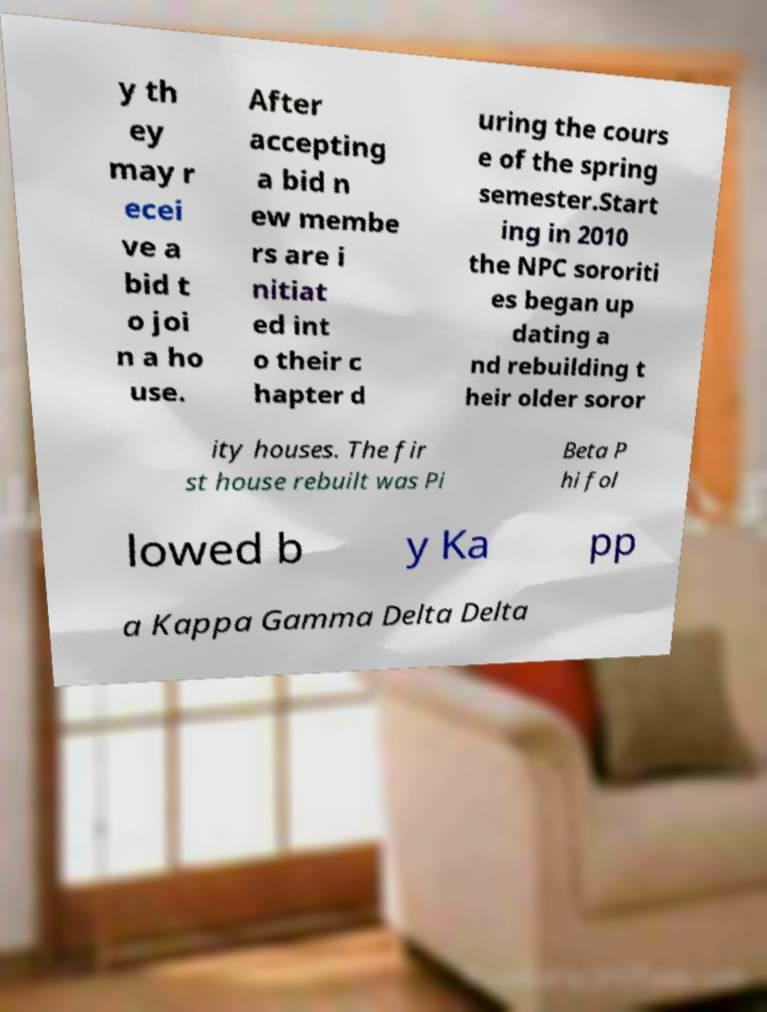I need the written content from this picture converted into text. Can you do that? y th ey may r ecei ve a bid t o joi n a ho use. After accepting a bid n ew membe rs are i nitiat ed int o their c hapter d uring the cours e of the spring semester.Start ing in 2010 the NPC sororiti es began up dating a nd rebuilding t heir older soror ity houses. The fir st house rebuilt was Pi Beta P hi fol lowed b y Ka pp a Kappa Gamma Delta Delta 